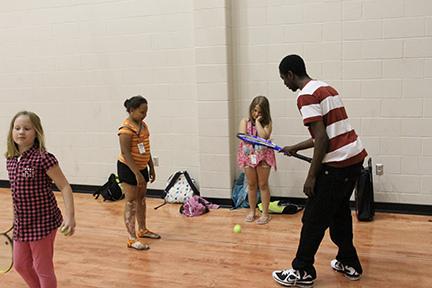Is the ball bouncing?
Short answer required. Yes. What color are the man's pants?
Be succinct. Black. Are any of these children in trouble?
Short answer required. No. How many girls are there?
Short answer required. 3. 